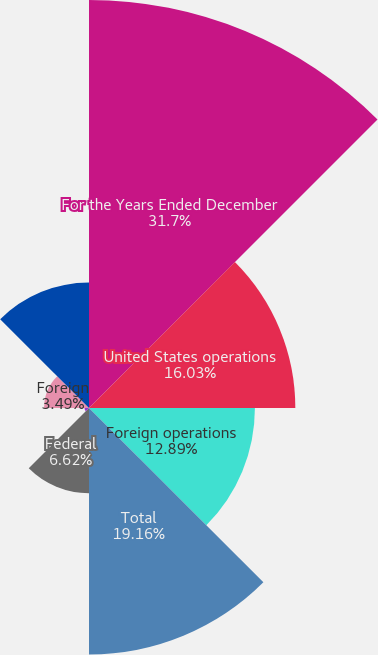Convert chart. <chart><loc_0><loc_0><loc_500><loc_500><pie_chart><fcel>For the Years Ended December<fcel>United States operations<fcel>Foreign operations<fcel>Total<fcel>Federal<fcel>State<fcel>Foreign<fcel>Provision for income taxes<nl><fcel>31.7%<fcel>16.03%<fcel>12.89%<fcel>19.16%<fcel>6.62%<fcel>0.35%<fcel>3.49%<fcel>9.76%<nl></chart> 